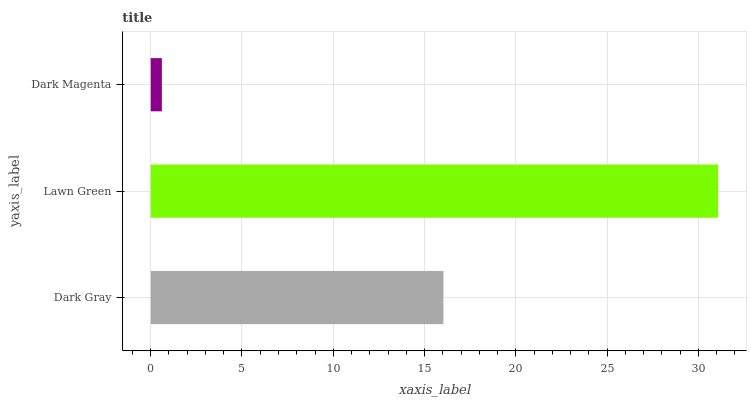Is Dark Magenta the minimum?
Answer yes or no. Yes. Is Lawn Green the maximum?
Answer yes or no. Yes. Is Lawn Green the minimum?
Answer yes or no. No. Is Dark Magenta the maximum?
Answer yes or no. No. Is Lawn Green greater than Dark Magenta?
Answer yes or no. Yes. Is Dark Magenta less than Lawn Green?
Answer yes or no. Yes. Is Dark Magenta greater than Lawn Green?
Answer yes or no. No. Is Lawn Green less than Dark Magenta?
Answer yes or no. No. Is Dark Gray the high median?
Answer yes or no. Yes. Is Dark Gray the low median?
Answer yes or no. Yes. Is Lawn Green the high median?
Answer yes or no. No. Is Lawn Green the low median?
Answer yes or no. No. 